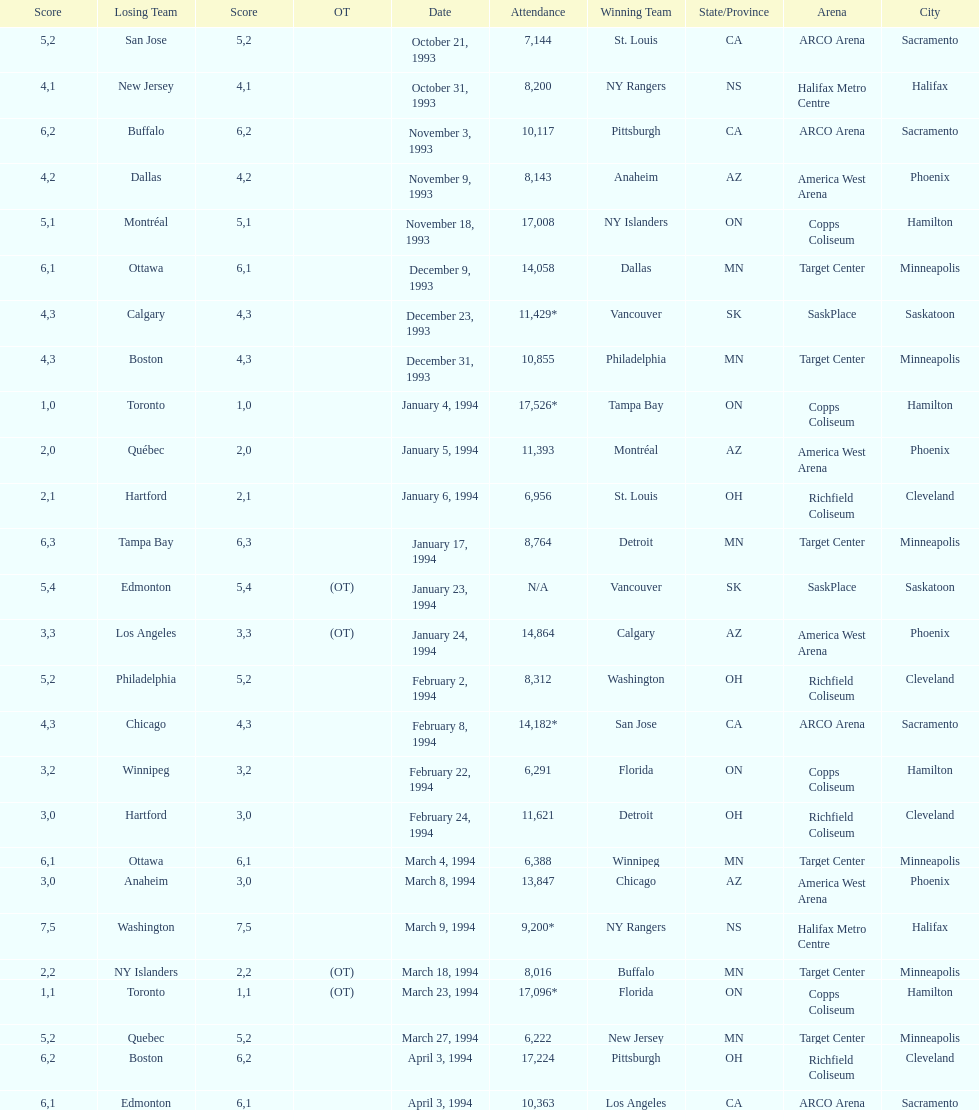When was the first neutral site game to be won by tampa bay? January 4, 1994. Help me parse the entirety of this table. {'header': ['Score', 'Losing Team', 'Score', 'OT', 'Date', 'Attendance', 'Winning Team', 'State/Province', 'Arena', 'City'], 'rows': [['5', 'San Jose', '2', '', 'October 21, 1993', '7,144', 'St. Louis', 'CA', 'ARCO Arena', 'Sacramento'], ['4', 'New Jersey', '1', '', 'October 31, 1993', '8,200', 'NY Rangers', 'NS', 'Halifax Metro Centre', 'Halifax'], ['6', 'Buffalo', '2', '', 'November 3, 1993', '10,117', 'Pittsburgh', 'CA', 'ARCO Arena', 'Sacramento'], ['4', 'Dallas', '2', '', 'November 9, 1993', '8,143', 'Anaheim', 'AZ', 'America West Arena', 'Phoenix'], ['5', 'Montréal', '1', '', 'November 18, 1993', '17,008', 'NY Islanders', 'ON', 'Copps Coliseum', 'Hamilton'], ['6', 'Ottawa', '1', '', 'December 9, 1993', '14,058', 'Dallas', 'MN', 'Target Center', 'Minneapolis'], ['4', 'Calgary', '3', '', 'December 23, 1993', '11,429*', 'Vancouver', 'SK', 'SaskPlace', 'Saskatoon'], ['4', 'Boston', '3', '', 'December 31, 1993', '10,855', 'Philadelphia', 'MN', 'Target Center', 'Minneapolis'], ['1', 'Toronto', '0', '', 'January 4, 1994', '17,526*', 'Tampa Bay', 'ON', 'Copps Coliseum', 'Hamilton'], ['2', 'Québec', '0', '', 'January 5, 1994', '11,393', 'Montréal', 'AZ', 'America West Arena', 'Phoenix'], ['2', 'Hartford', '1', '', 'January 6, 1994', '6,956', 'St. Louis', 'OH', 'Richfield Coliseum', 'Cleveland'], ['6', 'Tampa Bay', '3', '', 'January 17, 1994', '8,764', 'Detroit', 'MN', 'Target Center', 'Minneapolis'], ['5', 'Edmonton', '4', '(OT)', 'January 23, 1994', 'N/A', 'Vancouver', 'SK', 'SaskPlace', 'Saskatoon'], ['3', 'Los Angeles', '3', '(OT)', 'January 24, 1994', '14,864', 'Calgary', 'AZ', 'America West Arena', 'Phoenix'], ['5', 'Philadelphia', '2', '', 'February 2, 1994', '8,312', 'Washington', 'OH', 'Richfield Coliseum', 'Cleveland'], ['4', 'Chicago', '3', '', 'February 8, 1994', '14,182*', 'San Jose', 'CA', 'ARCO Arena', 'Sacramento'], ['3', 'Winnipeg', '2', '', 'February 22, 1994', '6,291', 'Florida', 'ON', 'Copps Coliseum', 'Hamilton'], ['3', 'Hartford', '0', '', 'February 24, 1994', '11,621', 'Detroit', 'OH', 'Richfield Coliseum', 'Cleveland'], ['6', 'Ottawa', '1', '', 'March 4, 1994', '6,388', 'Winnipeg', 'MN', 'Target Center', 'Minneapolis'], ['3', 'Anaheim', '0', '', 'March 8, 1994', '13,847', 'Chicago', 'AZ', 'America West Arena', 'Phoenix'], ['7', 'Washington', '5', '', 'March 9, 1994', '9,200*', 'NY Rangers', 'NS', 'Halifax Metro Centre', 'Halifax'], ['2', 'NY Islanders', '2', '(OT)', 'March 18, 1994', '8,016', 'Buffalo', 'MN', 'Target Center', 'Minneapolis'], ['1', 'Toronto', '1', '(OT)', 'March 23, 1994', '17,096*', 'Florida', 'ON', 'Copps Coliseum', 'Hamilton'], ['5', 'Quebec', '2', '', 'March 27, 1994', '6,222', 'New Jersey', 'MN', 'Target Center', 'Minneapolis'], ['6', 'Boston', '2', '', 'April 3, 1994', '17,224', 'Pittsburgh', 'OH', 'Richfield Coliseum', 'Cleveland'], ['6', 'Edmonton', '1', '', 'April 3, 1994', '10,363', 'Los Angeles', 'CA', 'ARCO Arena', 'Sacramento']]} 